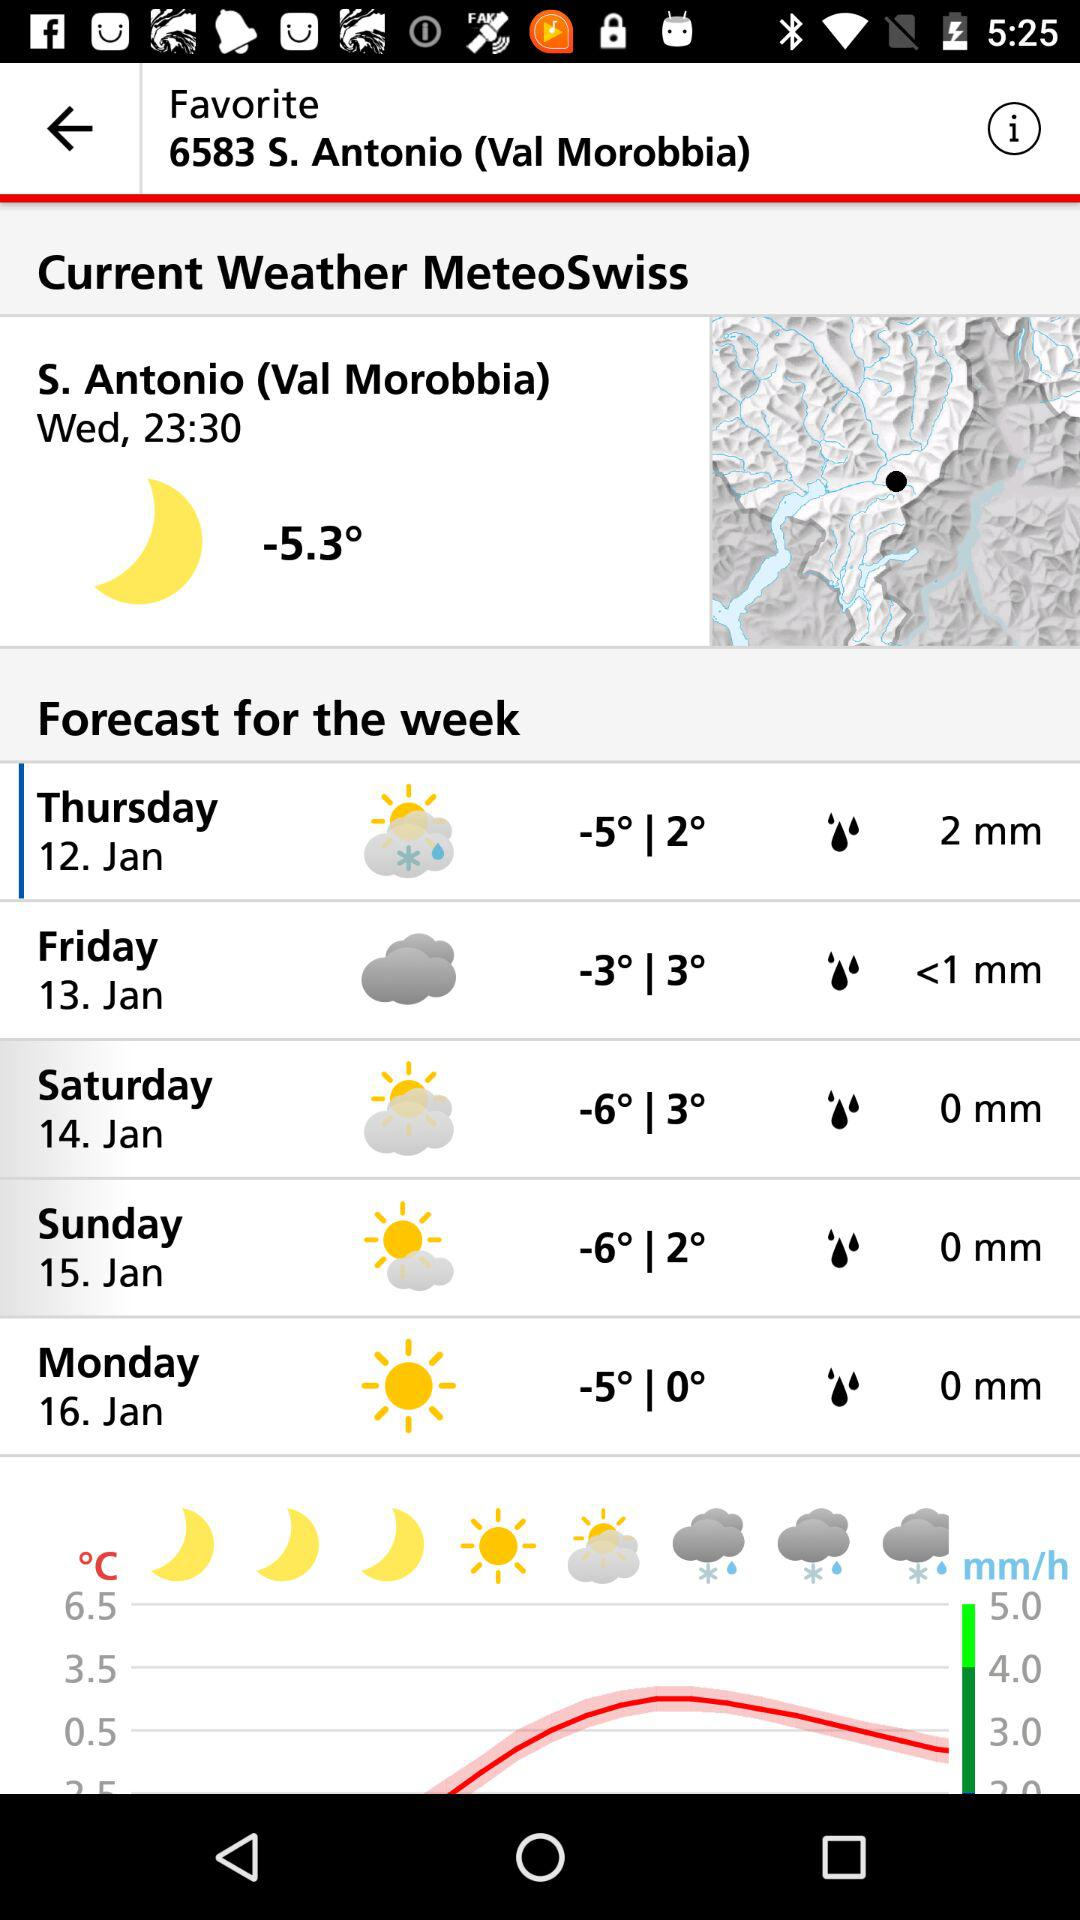What is the day of January 13? The day of January 13 is Friday. 